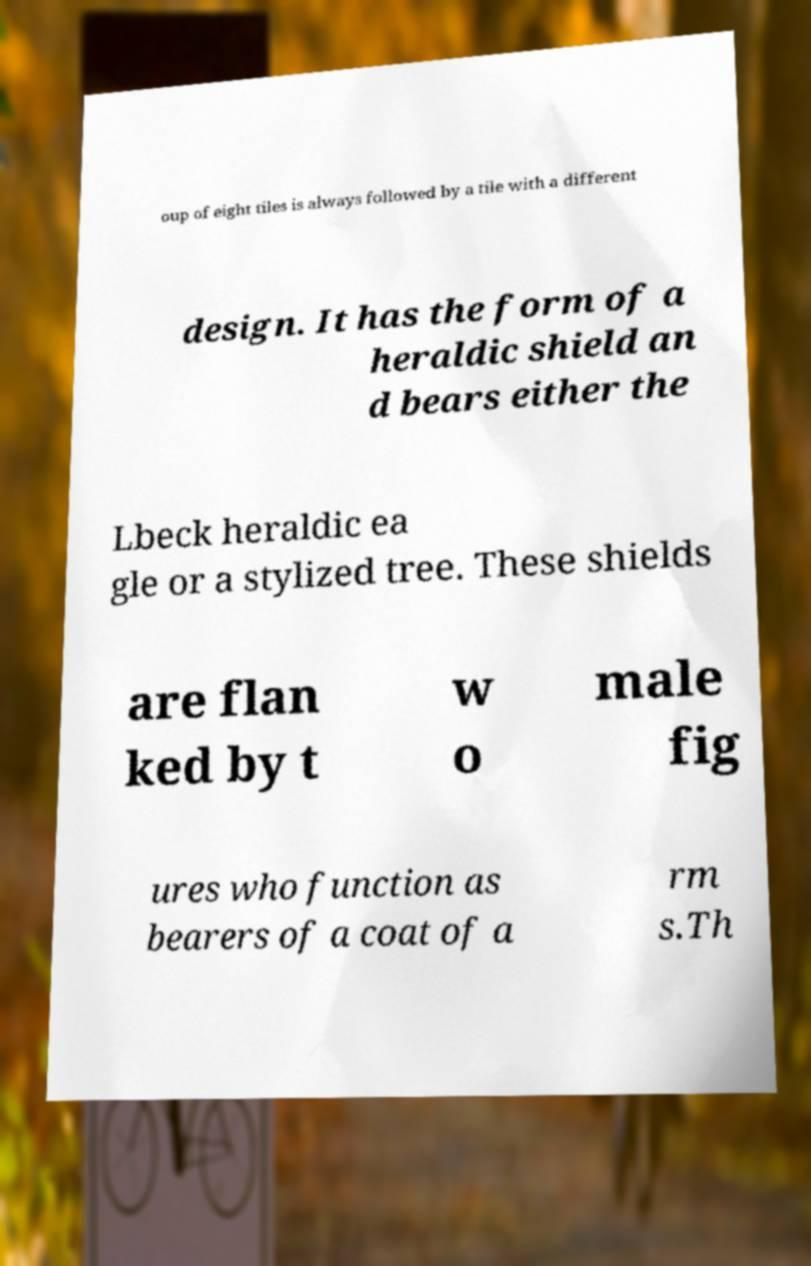Can you read and provide the text displayed in the image?This photo seems to have some interesting text. Can you extract and type it out for me? oup of eight tiles is always followed by a tile with a different design. It has the form of a heraldic shield an d bears either the Lbeck heraldic ea gle or a stylized tree. These shields are flan ked by t w o male fig ures who function as bearers of a coat of a rm s.Th 